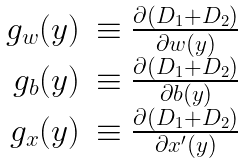Convert formula to latex. <formula><loc_0><loc_0><loc_500><loc_500>\begin{array} { r l } g _ { w } ( y ) & \equiv \frac { \partial \left ( D _ { 1 } + D _ { 2 } \right ) } { \partial w ( y ) } \\ g _ { b } ( y ) & \equiv \frac { \partial \left ( D _ { 1 } + D _ { 2 } \right ) } { \partial b ( y ) } \\ g _ { x } ( y ) & \equiv \frac { \partial \left ( D _ { 1 } + D _ { 2 } \right ) } { \partial x ^ { \prime } ( y ) } \end{array}</formula> 